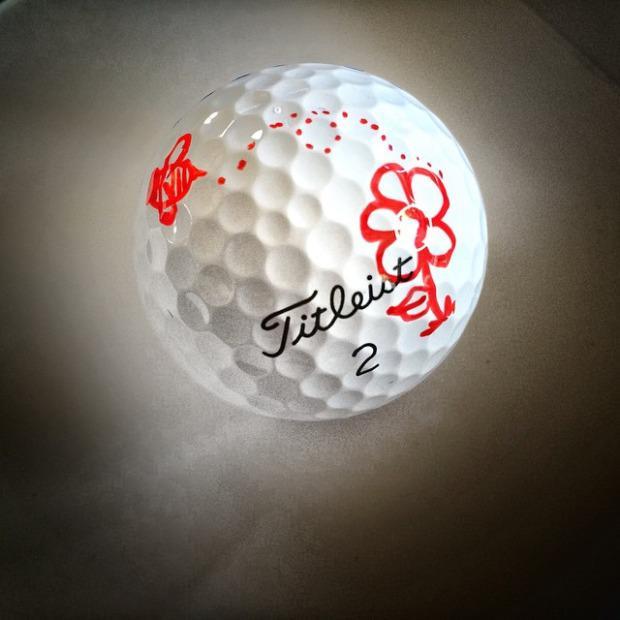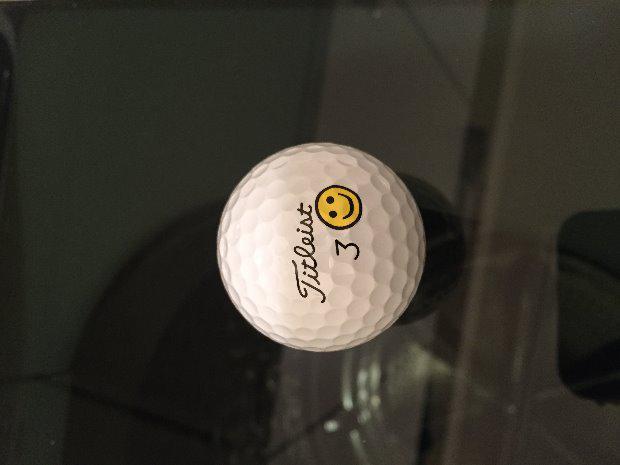The first image is the image on the left, the second image is the image on the right. Examine the images to the left and right. Is the description "The left image is a golf ball with a flower on it." accurate? Answer yes or no. Yes. 